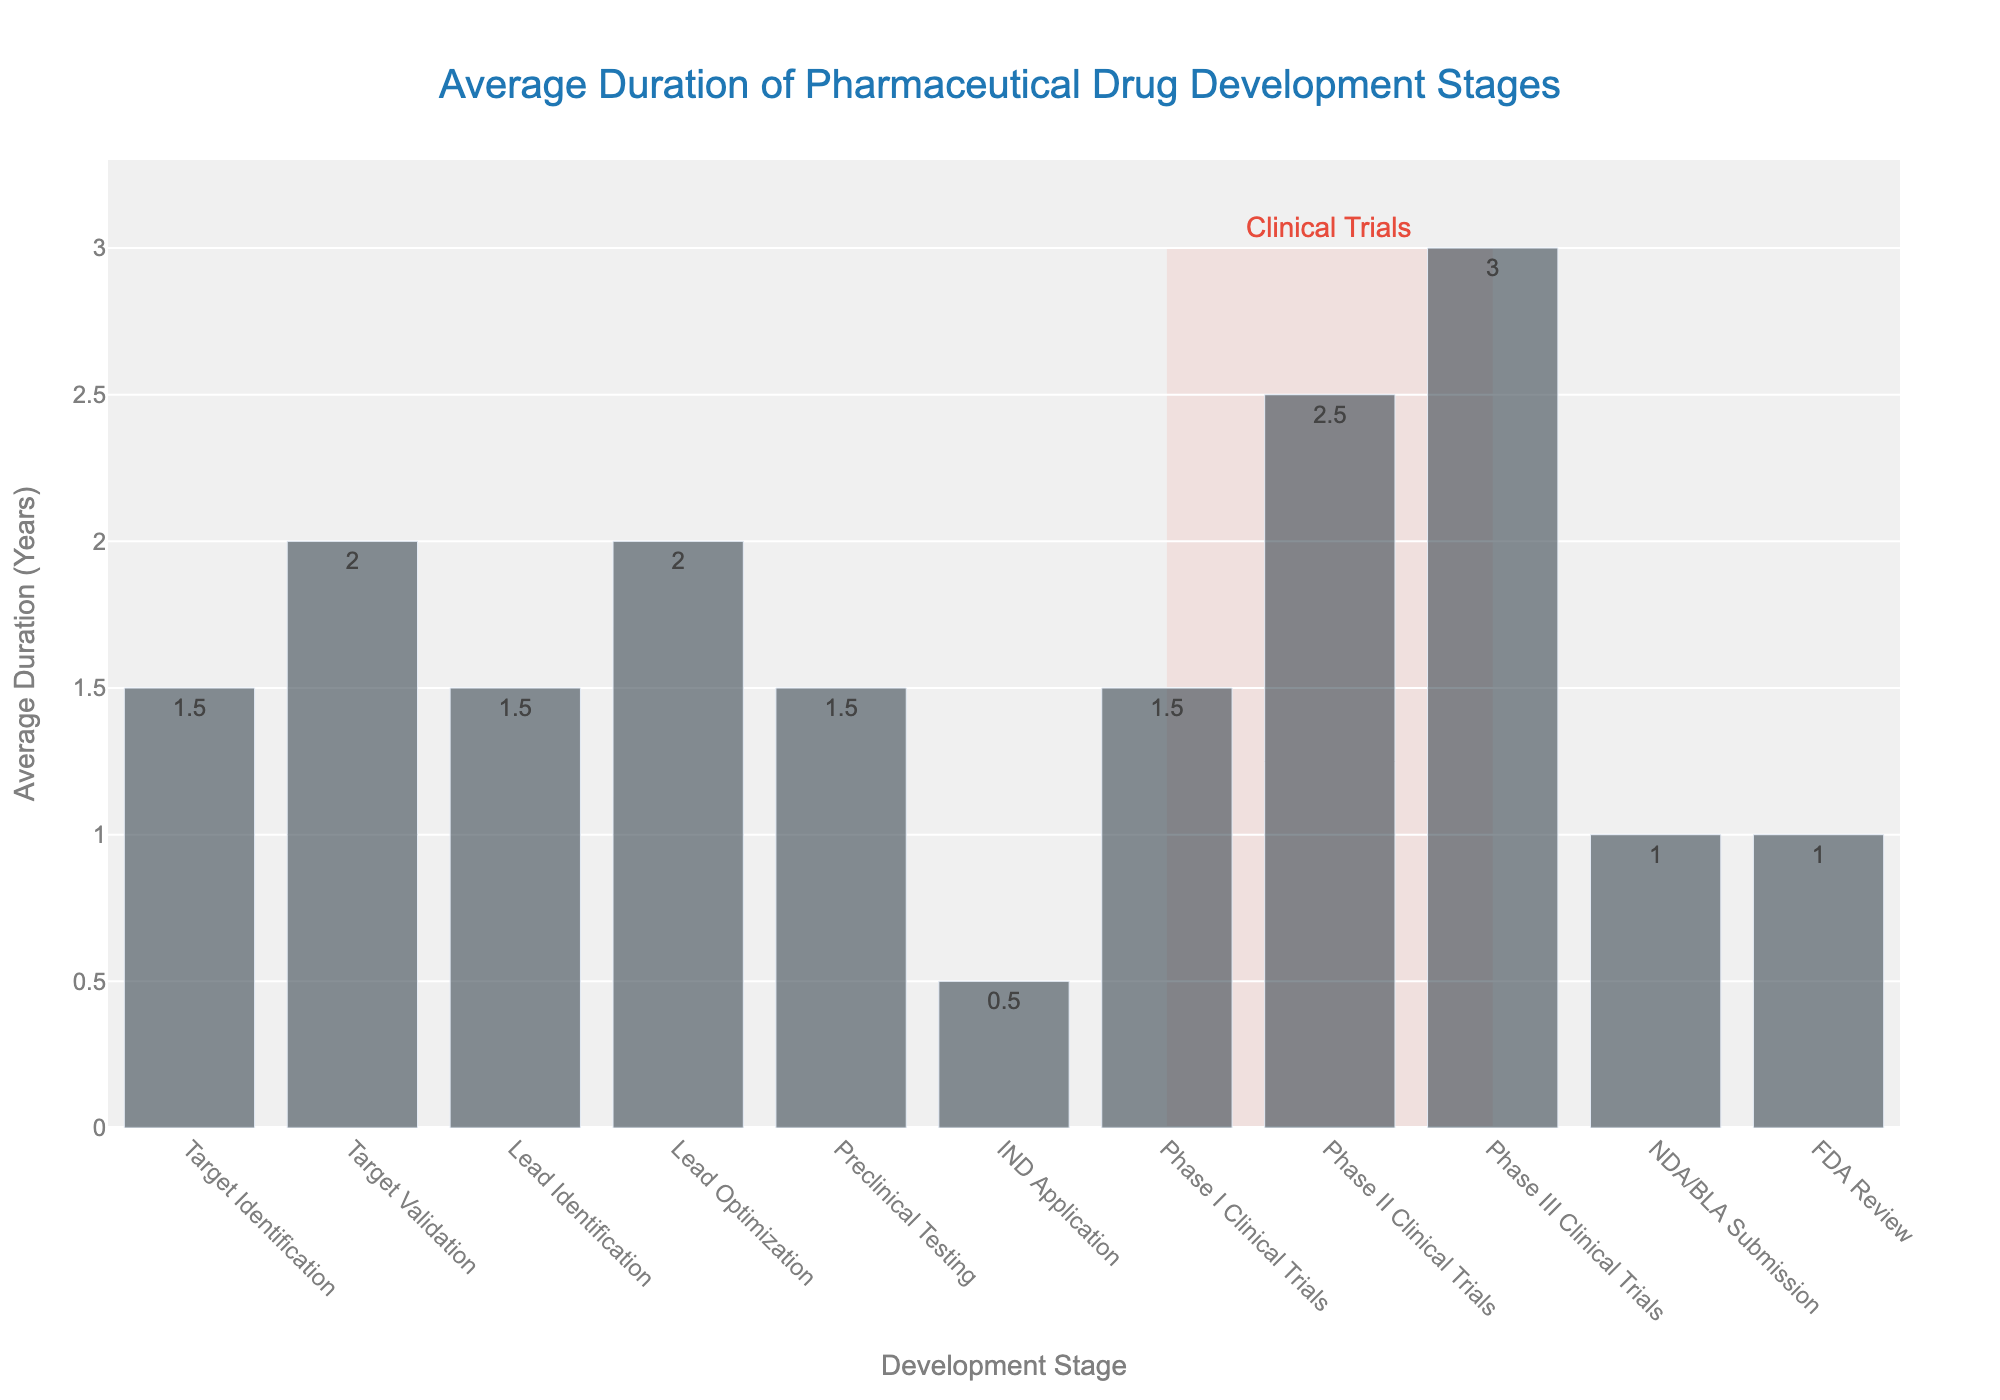What is the average duration for the Phase III Clinical Trials stage? Look at the bar labeled "Phase III Clinical Trials" on the x-axis and check its height to find the average duration.
Answer: 3 years What is the total duration from Target Identification to Lead Optimization? Add the durations for "Target Identification", "Target Validation", "Lead Identification", and "Lead Optimization". The respective durations are 1.5, 2, 1.5, and 2 years. So, the total is 1.5 + 2 + 1.5 + 2 = 7 years.
Answer: 7 years Which stage takes the shortest time on average, and how long is it? Identify the shortest bar on the chart, which corresponds to the "IND Application" stage. Observe its height, which indicates the duration.
Answer: IND Application, 0.5 years How much longer does the NDA/BLA Submission stage take compared to the IND Application stage? Check the durations for "NDA/BLA Submission" and "IND Application". These are 1 year and 0.5 years respectively. Subtract the IND Application duration from the NDA/BLA Submission duration: 1 - 0.5 = 0.5 years.
Answer: 0.5 years What stages are highlighted by the rectangle shape, and what does this highlight signify? The rectangle highlights the "Phase I Clinical Trials", "Phase II Clinical Trials", and "Phase III Clinical Trials" stages. These stages are collectively referred to as "Clinical Trials".
Answer: Phase I Clinical Trials, Phase II Clinical Trials, Phase III Clinical Trials; Clinical Trials Is the average duration for Preclinical Testing longer than that for Lead Identification? Compare the heights of the bars labeled "Preclinical Testing" and "Lead Identification". Both have an average duration of 1.5 years. Thus, neither is longer.
Answer: No By how much does the average duration of Phase II Clinical Trials exceed that of Phase I Clinical Trials? Check the durations for "Phase II Clinical Trials" and "Phase I Clinical Trials". The durations are 2.5 years and 1.5 years respectively. Subtract the duration of Phase I Clinical Trials from that of Phase II Clinical Trials: 2.5 - 1.5 = 1 year.
Answer: 1 year Which stages have an average duration of 1.5 years? Identify all bars with a height of 1.5 years. These correspond to the stages "Target Identification", "Lead Identification", "Preclinical Testing", and "Phase I Clinical Trials".
Answer: Target Identification, Lead Identification, Preclinical Testing, Phase I Clinical Trials What's the total duration for all stages leading up to and including Phase III Clinical Trials? Sum the durations for all stages from "Target Identification" to "Phase III Clinical Trials". The total is 1.5 + 2 + 1.5 + 2 + 1.5 + 0.5 + 1.5 + 2.5 + 3 = 16 years.
Answer: 16 years Which stage comes right after Lead Optimization in the drug development process? Look at the sequence of the stages on the x-axis to find the one following "Lead Optimization", which is "Preclinical Testing".
Answer: Preclinical Testing 